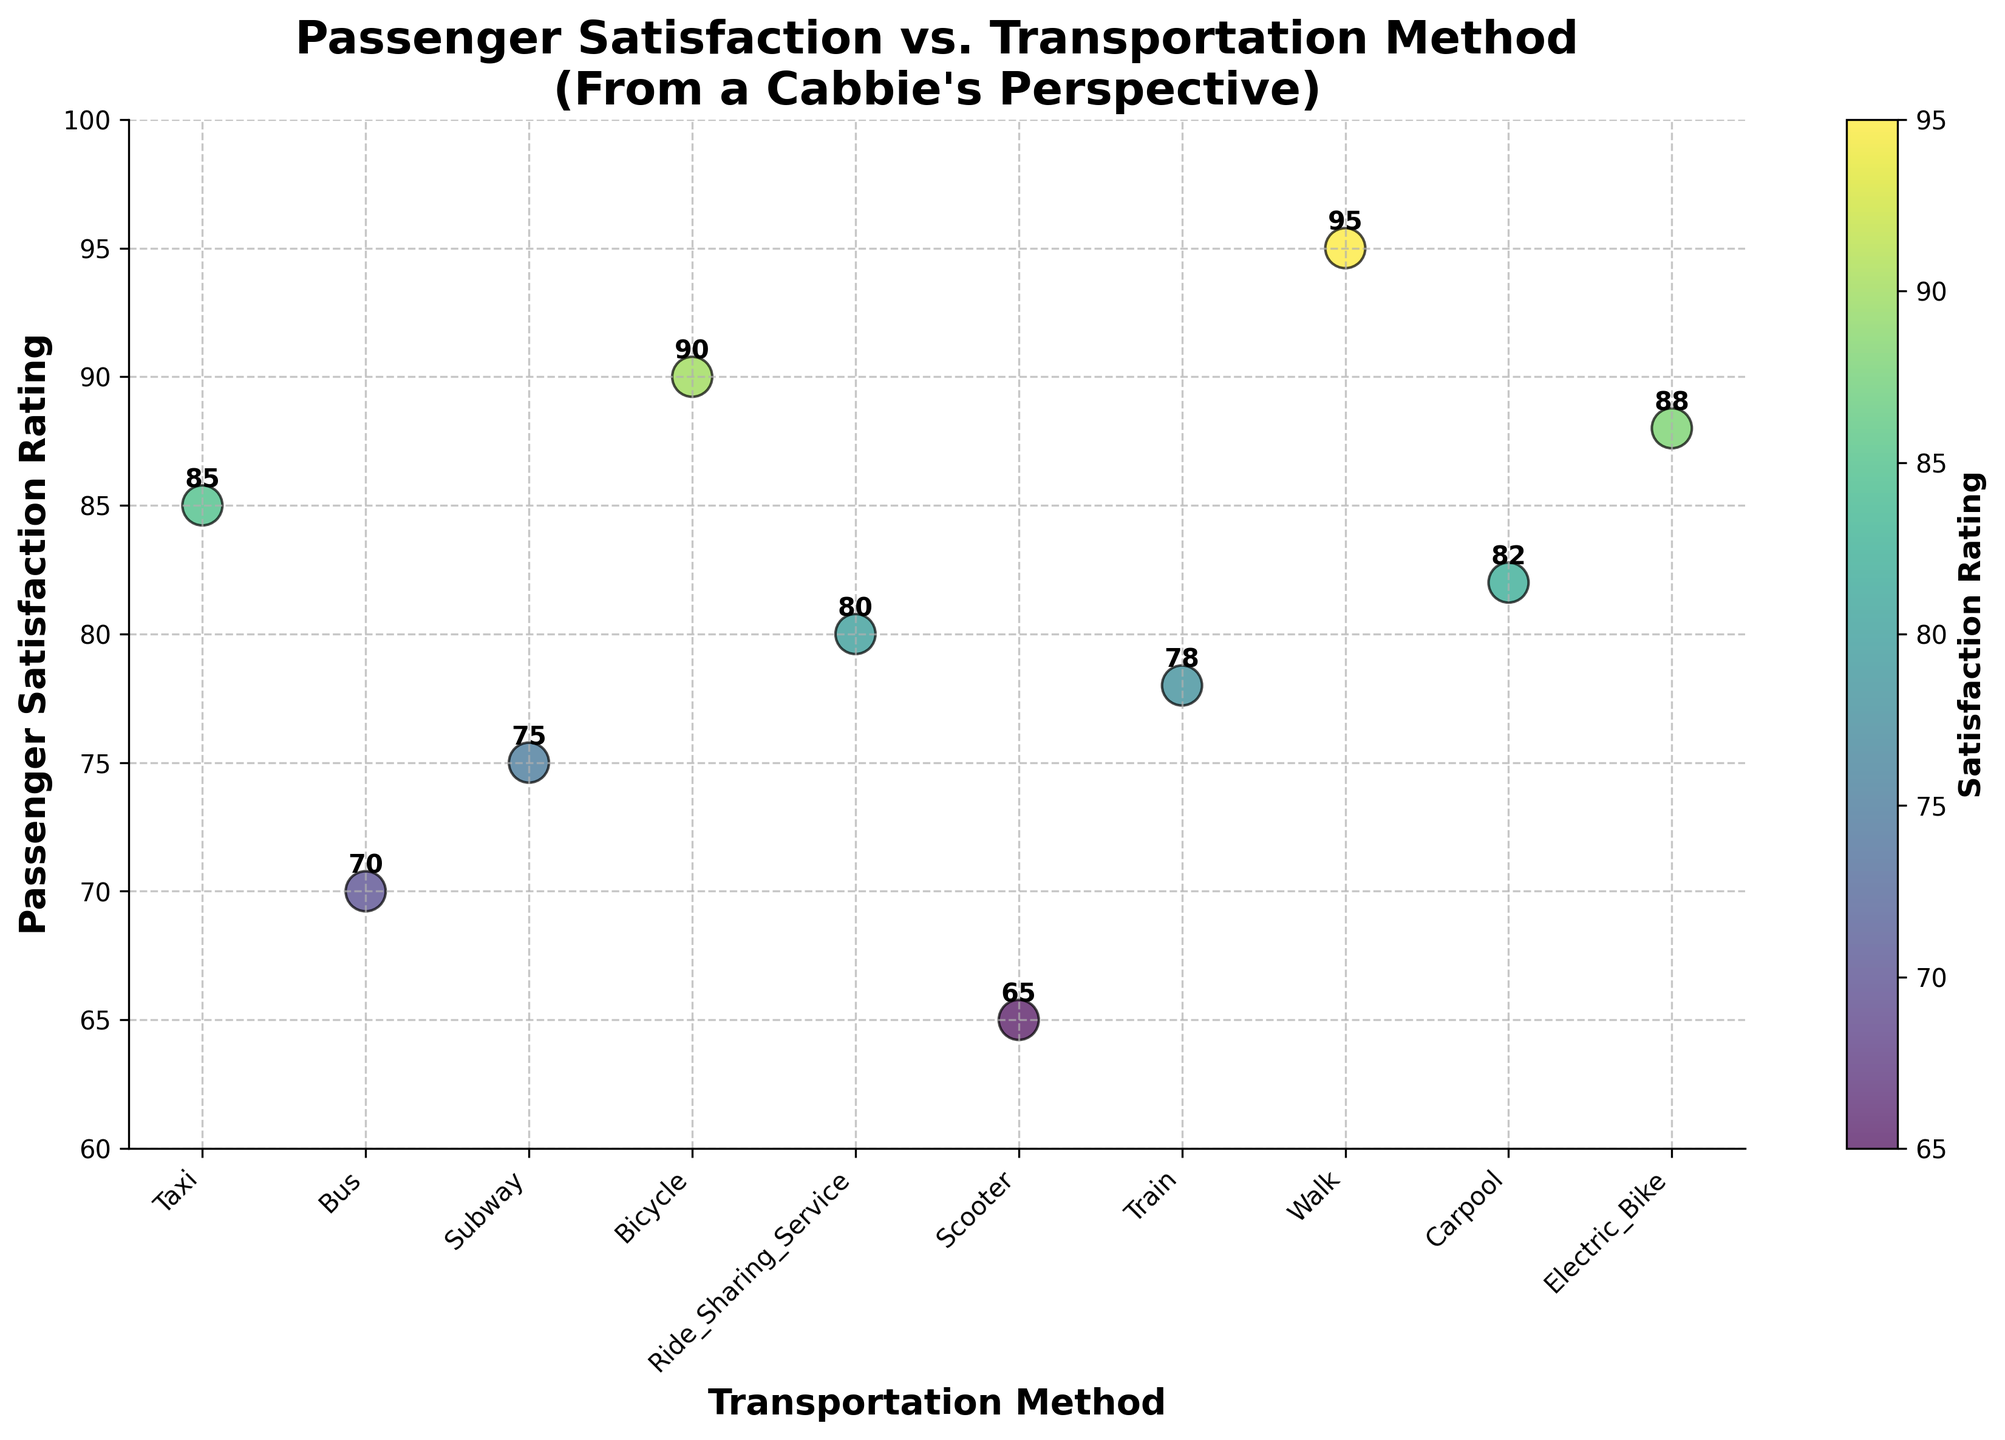What's the title of the figure? The title is located at the top of the figure. It helps viewers quickly understand what the figure is depicting. The title is "Passenger Satisfaction vs. Transportation Method\n(From a Cabbie's Perspective)."
Answer: "Passenger Satisfaction vs. Transportation Method\n(From a Cabbie's Perspective)" What transportation method has the highest passenger satisfaction rating? To find this, look at the y-axis for the highest value and identify the corresponding transportation method on the x-axis. The highest rating is 95, associated with "Walk."
Answer: Walk What is the satisfaction rating for using a bicycle? Locate the "Bicycle" label on the x-axis and follow it up to the corresponding point on the y-axis. The rating for "Bicycle" is 90.
Answer: 90 How many transportation methods have a satisfaction rating of 80 or more? Count the number of points on the figure which have y-axis values of 80 or more. There are six points: Taxi, Ride_Sharing_Service, Walk, Carpool, Bicycle, and Electric_Bike.
Answer: 6 Which two transportation methods have the closest passenger satisfaction ratings? Identify pairs of points with the smallest difference in their y-axis (satisfaction rating) values. "Ride_Sharing_Service" (80) and "Carpool" (82) have the closest ratings, with a difference of 2 points.
Answer: Ride_Sharing_Service and Carpool What transportation methods have satisfaction ratings lower than 75? Look for points on the y-axis that are below 75 and identify the corresponding labels on the x-axis. The methods are Bus (70) and Scooter (65).
Answer: Bus and Scooter What is the median passenger satisfaction rating? Arrange all satisfaction ratings in ascending order: 65, 70, 75, 78, 80, 82, 85, 88, 90, 95. The median is the middle value of this sorted list, which is 82 (if the list has an even number of values, the median would be the average of the two middle numbers).
Answer: 82 Which transportation method has a lower passenger satisfaction rating: Train or Scooter? Compare the y-axis values for "Train" and "Scooter." The "Train" rating is 78, and "Scooter" is 65. "Scooter" has a lower rating.
Answer: Scooter What is the average satisfaction rating across all transportation methods? Sum all ratings and divide by the number of methods: (85 + 70 + 75 + 90 + 80 + 65 + 78 + 95 + 82 + 88) / 10 = 808 / 10 = 80.8.
Answer: 80.8 What is the range of passenger satisfaction ratings in the figure? Calculate the range by finding the difference between the highest and lowest ratings. The highest rating is 95 (Walk) and the lowest is 65 (Scooter), so the range is 95 - 65 = 30.
Answer: 30 